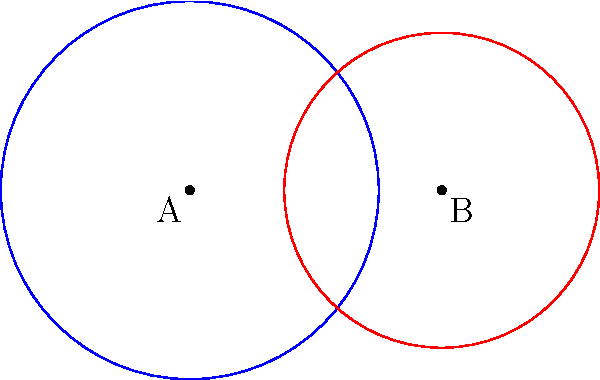In a handball training exercise, two goal zones are represented by overlapping circles. Circle A has a radius of 3 meters, and circle B has a radius of 2.5 meters. If the centers of the circles are 4 meters apart, what is the area of the overlapping region in square meters? Round your answer to two decimal places. Let's solve this step-by-step:

1) First, we need to find the distance from the center of each circle to the points where the circles intersect. Let's call this distance $x$ for circle A and $y$ for circle B.

2) Using the Pythagorean theorem:
   $x^2 + y^2 = 4^2 = 16$
   $(3-x)^2 + y^2 = 2.5^2 = 6.25$

3) Subtracting these equations:
   $3^2 - (3-x)^2 = 16 - 6.25$
   $9 - (9-6x+x^2) = 9.75$
   $6x - x^2 = 9.75$
   $x^2 - 6x + 9.75 = 0$

4) Solving this quadratic equation:
   $x = \frac{6 \pm \sqrt{36-4(1)(9.75)}}{2(1)} = \frac{6 \pm \sqrt{-3}}{2}$
   $x = 3 - \frac{\sqrt{3}}{2} \approx 2.134$ meters

5) Now we can find $y$:
   $y = \sqrt{3^2 - x^2} \approx 2.134$ meters

6) The area of overlap can be calculated using the formula:
   $A = 2(r_1^2 \arccos(\frac{x}{r_1}) - x\sqrt{r_1^2-x^2}) + 2(r_2^2 \arccos(\frac{x}{r_2}) - x\sqrt{r_2^2-x^2})$

7) Plugging in our values:
   $A = 2(3^2 \arccos(\frac{2.134}{3}) - 2.134\sqrt{3^2-2.134^2}) + 2(2.5^2 \arccos(\frac{2.134}{2.5}) - 2.134\sqrt{2.5^2-2.134^2})$

8) Calculating this (using a calculator):
   $A \approx 7.16$ square meters

9) Rounding to two decimal places:
   $A \approx 7.16$ square meters
Answer: 7.16 square meters 